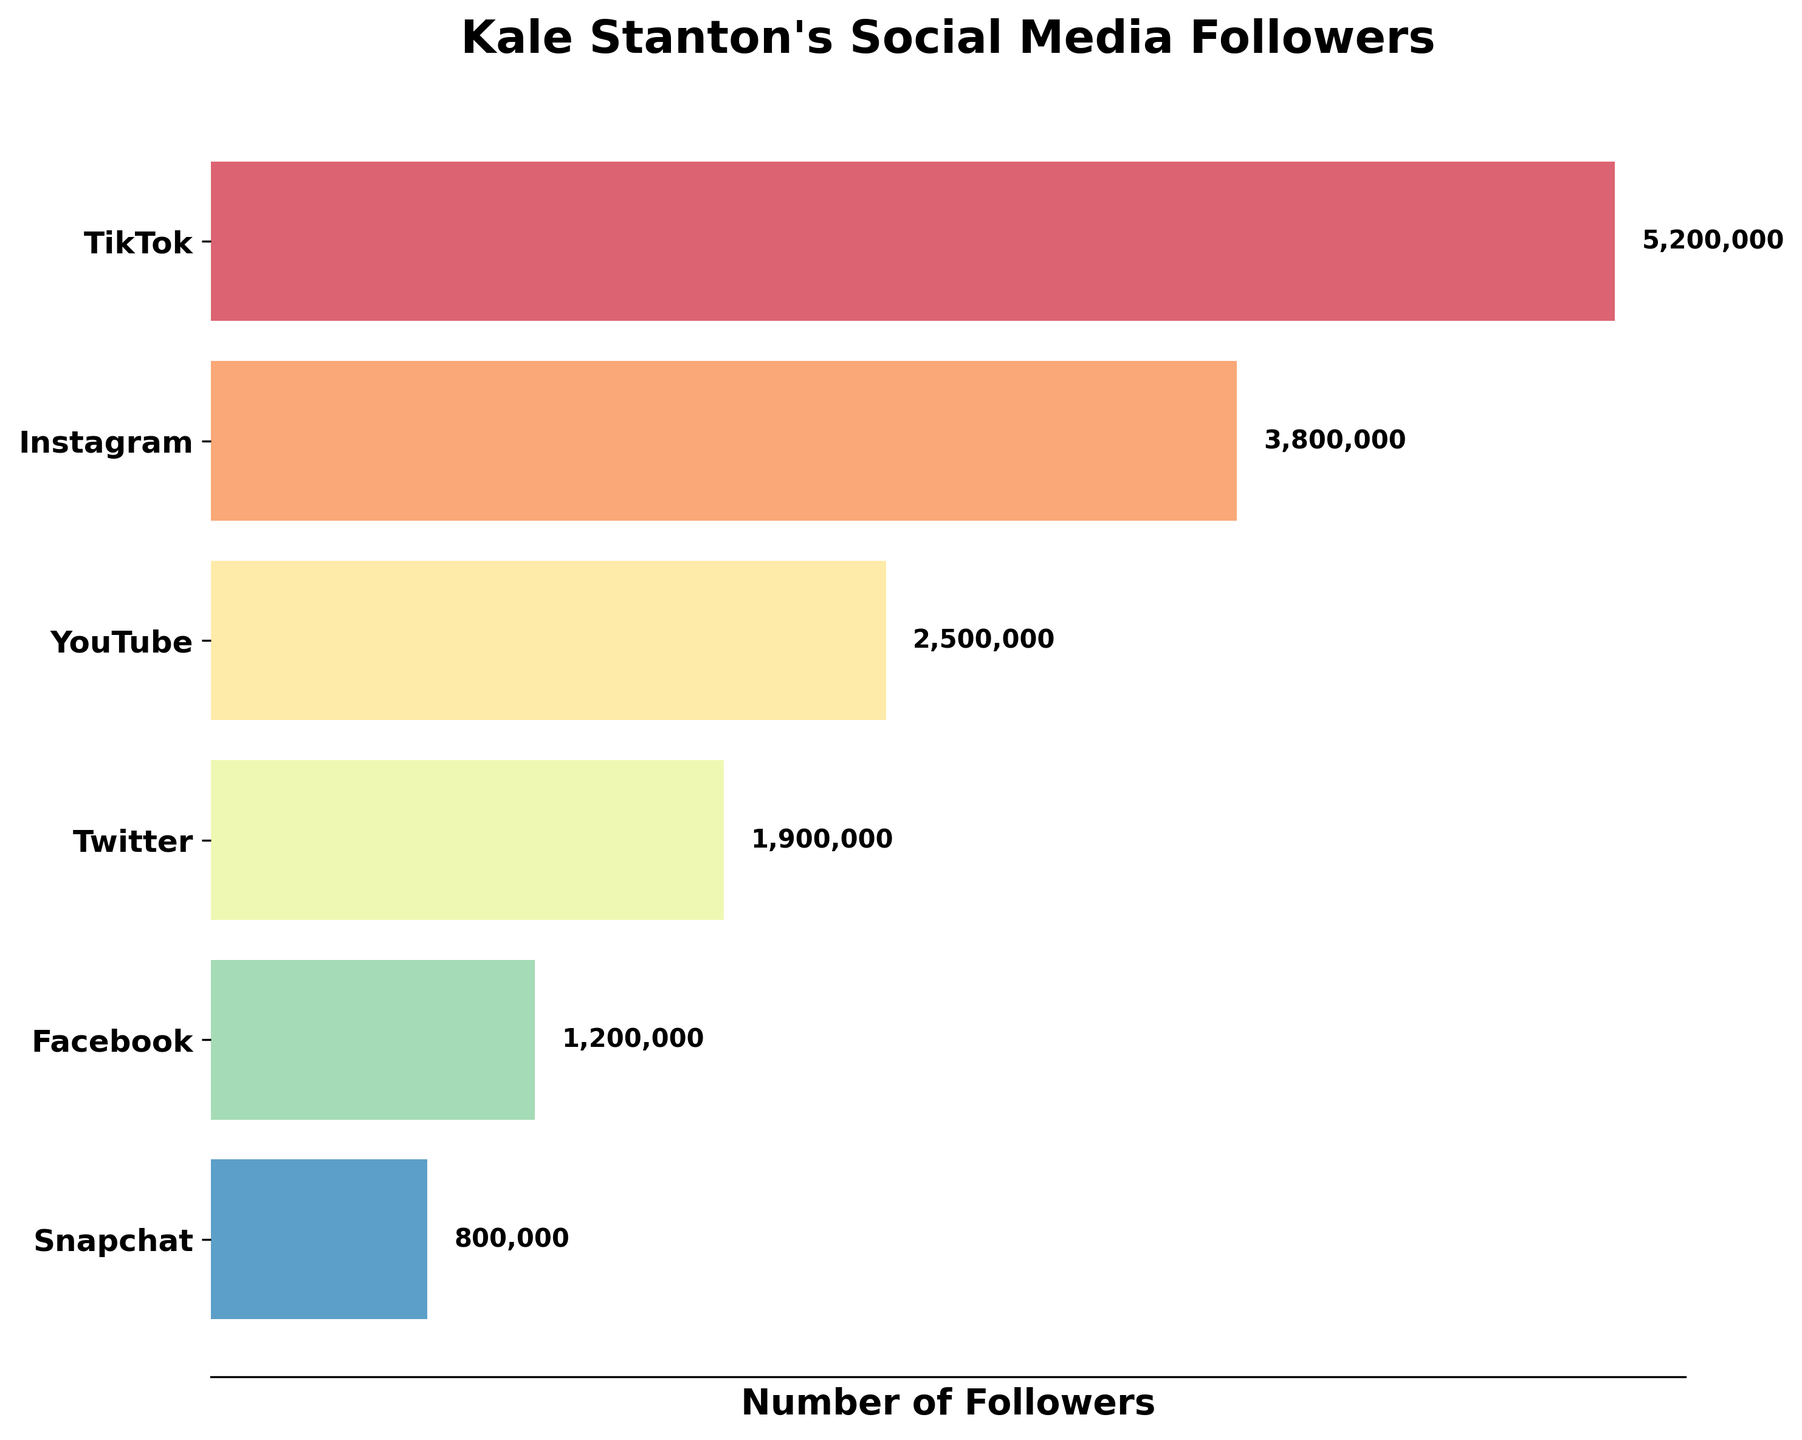How many social media platforms are represented in the chart? You can count the number of unique bars in the funnel chart, each representing a different social media platform.
Answer: 6 Which platform has the highest number of followers? The bar at the top of the funnel chart represents the platform with the highest number of followers.
Answer: TikTok What is the title of the chart? The title is typically displayed at the top of the chart in a large font.
Answer: Kale Stanton's Social Media Followers What is the total number of followers across all platforms? Sum the number of followers for each platform (5,200,000 + 3,800,000 + 2,500,000 + 1,900,000 + 1,200,000 + 800,000).
Answer: 15,400,000 How many more followers does Instagram have compared to YouTube? Subtract the number of followers of YouTube from Instagram (3,800,000 - 2,500,000).
Answer: 1,300,000 Which two platforms have the smallest difference in followers, and what is that difference? Calculate the differences between all adjacent platform follower counts in the chart and identify the smallest difference (difference between Twitter and Facebook is the smallest).
Answer: Twitter and Facebook, 700,000 What percentage of the total followers does Snapchat have? Calculate the percentage by dividing Snapchat's followers by the total followers and multiplying by 100 ((800,000 / 15,400,000) * 100).
Answer: 5.19% Which platform has the least number of followers? The bar at the bottom of the funnel chart represents the platform with the least number of followers.
Answer: Snapchat Arrange the platforms in descending order of their follower counts. Order the platforms by their follower counts from highest to lowest: TikTok > Instagram > YouTube > Twitter > Facebook > Snapchat.
Answer: TikTok, Instagram, YouTube, Twitter, Facebook, Snapchat How many followers would Kale need to gain on Twitter to surpass YouTube in followers? Subtract the number of Twitter followers from YouTube followers (2,500,000 - 1,900,000).
Answer: 600,000 